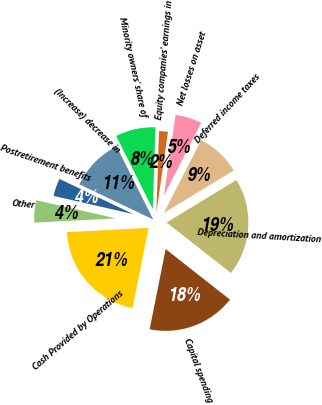Convert chart. <chart><loc_0><loc_0><loc_500><loc_500><pie_chart><fcel>Depreciation and amortization<fcel>Deferred income taxes<fcel>Net losses on asset<fcel>Equity companies' earnings in<fcel>Minority owners' share of<fcel>(Increase) decrease in<fcel>Postretirement benefits<fcel>Other<fcel>Cash Provided by Operations<fcel>Capital spending<nl><fcel>19.29%<fcel>8.77%<fcel>5.27%<fcel>1.76%<fcel>7.9%<fcel>10.53%<fcel>3.51%<fcel>4.39%<fcel>21.04%<fcel>17.54%<nl></chart> 